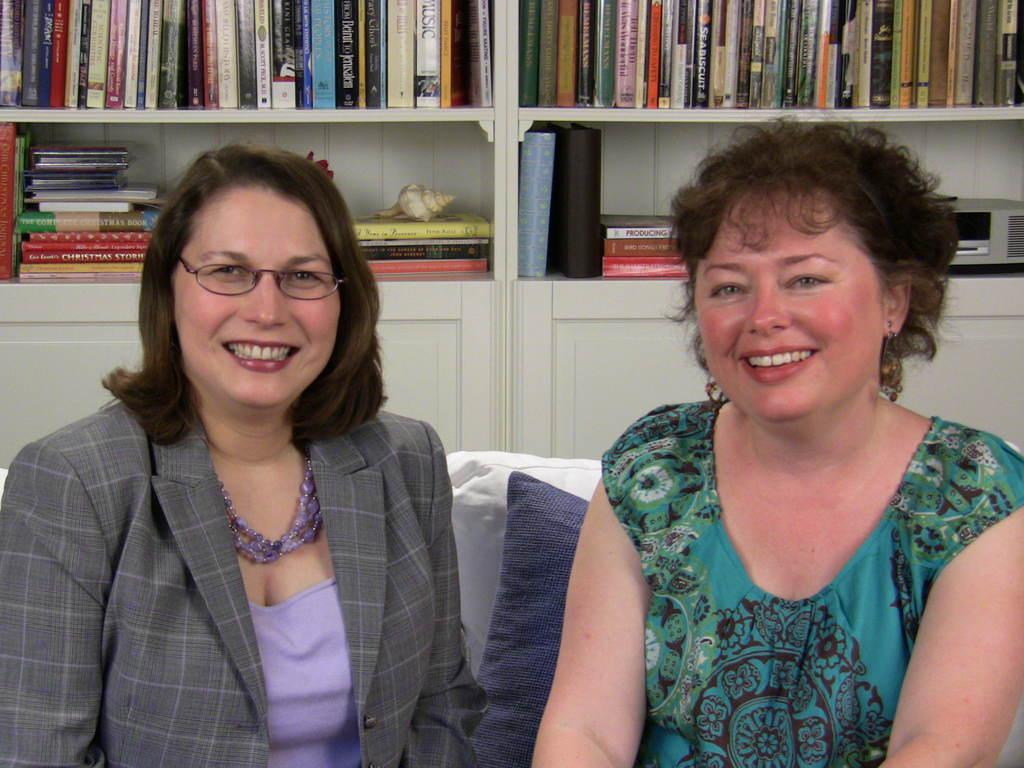In one or two sentences, can you explain what this image depicts? In this image we can see two women sitting. We can also see the cushions. On the backside we can see a group of books, a device and a shell which are placed in the shelves. 